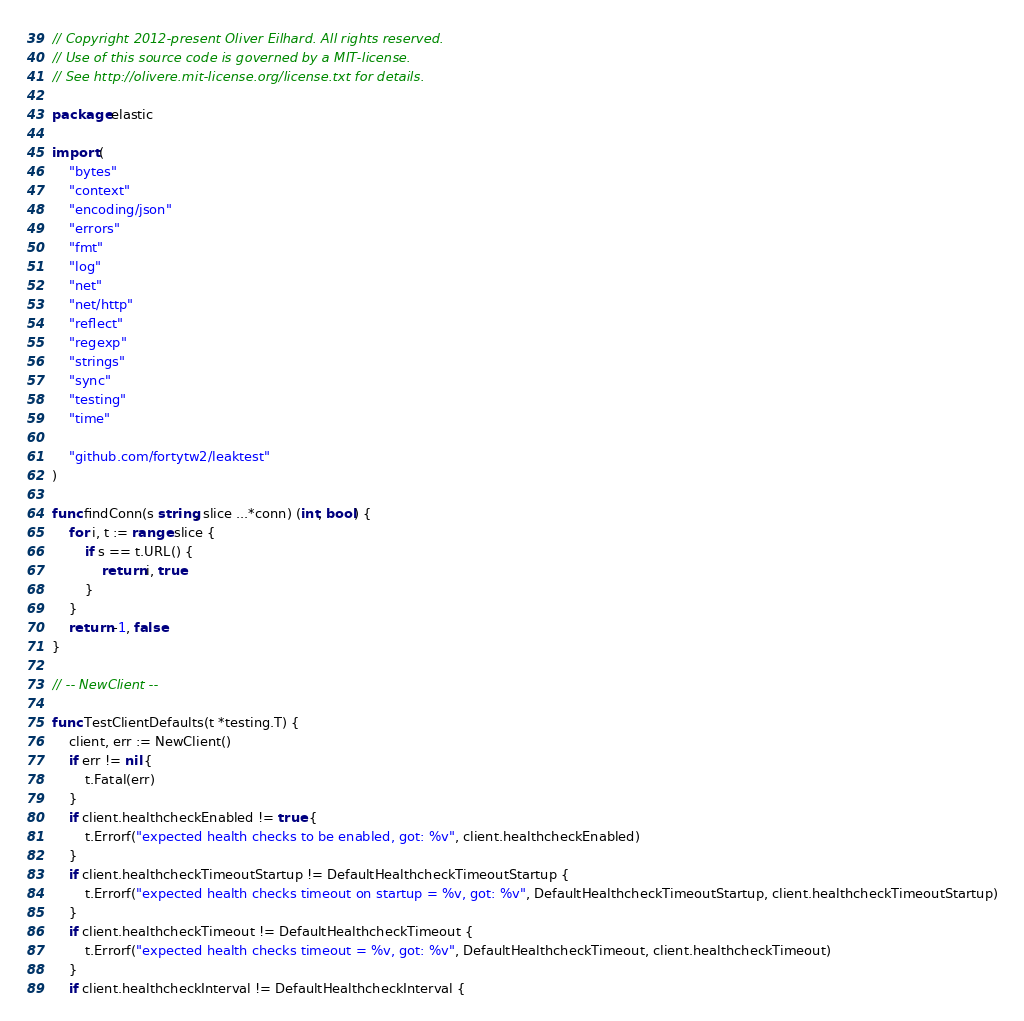Convert code to text. <code><loc_0><loc_0><loc_500><loc_500><_Go_>// Copyright 2012-present Oliver Eilhard. All rights reserved.
// Use of this source code is governed by a MIT-license.
// See http://olivere.mit-license.org/license.txt for details.

package elastic

import (
	"bytes"
	"context"
	"encoding/json"
	"errors"
	"fmt"
	"log"
	"net"
	"net/http"
	"reflect"
	"regexp"
	"strings"
	"sync"
	"testing"
	"time"

	"github.com/fortytw2/leaktest"
)

func findConn(s string, slice ...*conn) (int, bool) {
	for i, t := range slice {
		if s == t.URL() {
			return i, true
		}
	}
	return -1, false
}

// -- NewClient --

func TestClientDefaults(t *testing.T) {
	client, err := NewClient()
	if err != nil {
		t.Fatal(err)
	}
	if client.healthcheckEnabled != true {
		t.Errorf("expected health checks to be enabled, got: %v", client.healthcheckEnabled)
	}
	if client.healthcheckTimeoutStartup != DefaultHealthcheckTimeoutStartup {
		t.Errorf("expected health checks timeout on startup = %v, got: %v", DefaultHealthcheckTimeoutStartup, client.healthcheckTimeoutStartup)
	}
	if client.healthcheckTimeout != DefaultHealthcheckTimeout {
		t.Errorf("expected health checks timeout = %v, got: %v", DefaultHealthcheckTimeout, client.healthcheckTimeout)
	}
	if client.healthcheckInterval != DefaultHealthcheckInterval {</code> 